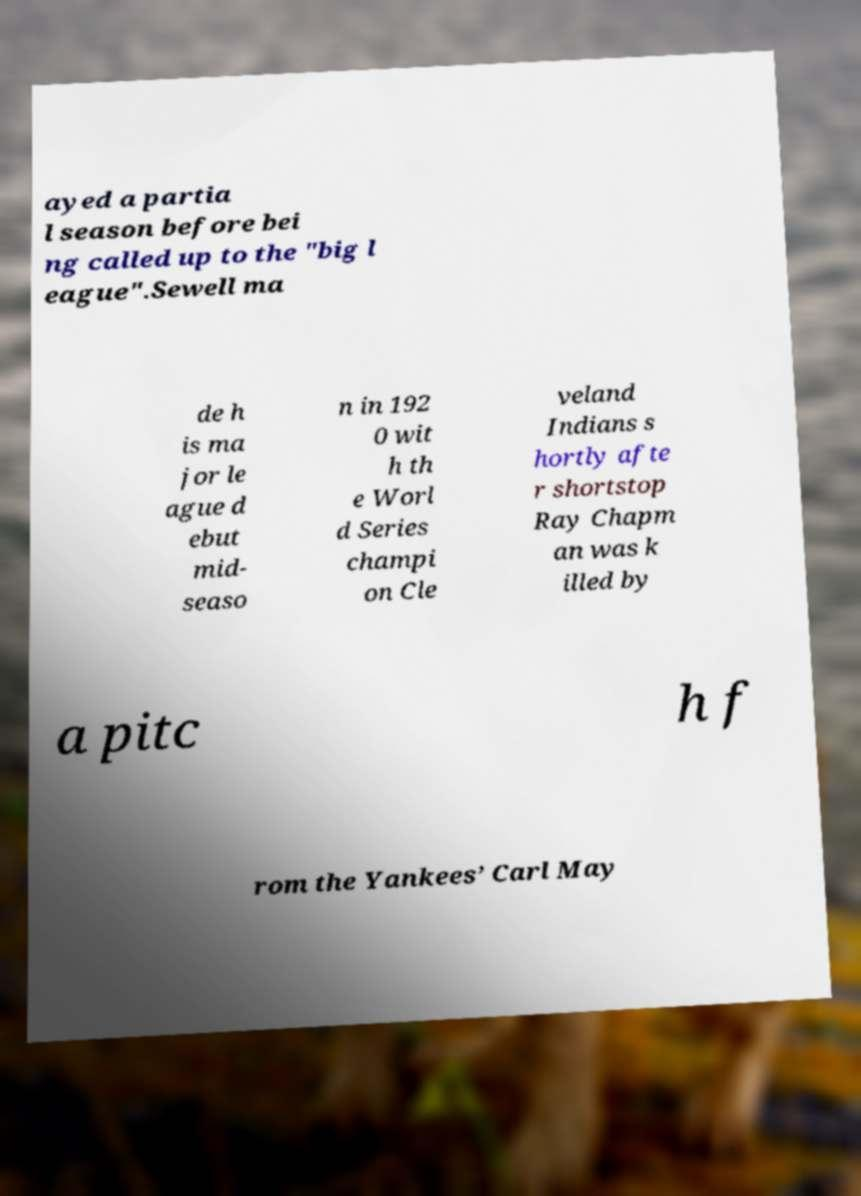Could you extract and type out the text from this image? ayed a partia l season before bei ng called up to the "big l eague".Sewell ma de h is ma jor le ague d ebut mid- seaso n in 192 0 wit h th e Worl d Series champi on Cle veland Indians s hortly afte r shortstop Ray Chapm an was k illed by a pitc h f rom the Yankees’ Carl May 